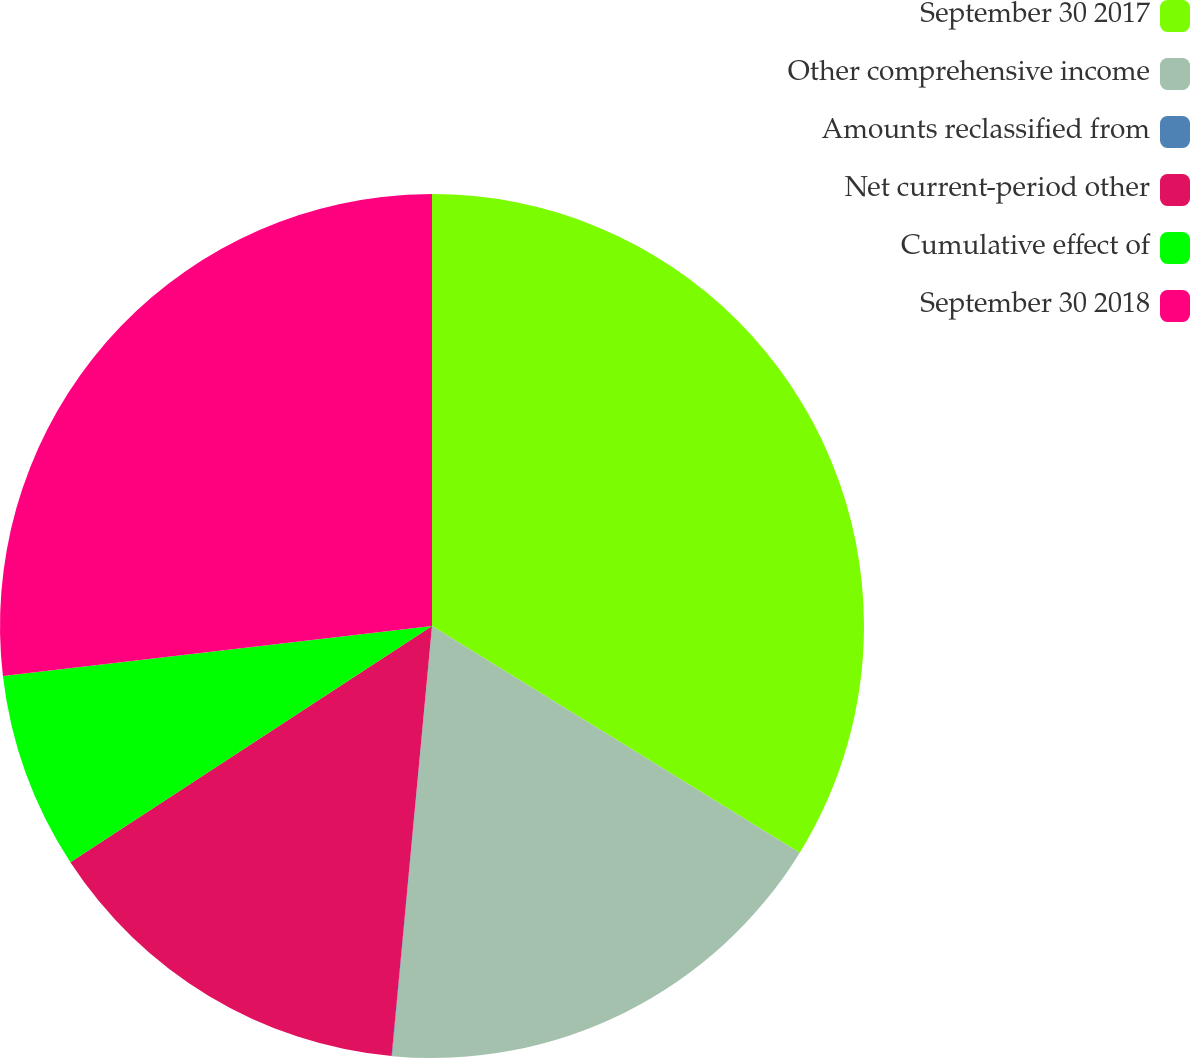Convert chart to OTSL. <chart><loc_0><loc_0><loc_500><loc_500><pie_chart><fcel>September 30 2017<fcel>Other comprehensive income<fcel>Amounts reclassified from<fcel>Net current-period other<fcel>Cumulative effect of<fcel>September 30 2018<nl><fcel>33.79%<fcel>17.68%<fcel>0.02%<fcel>14.3%<fcel>7.36%<fcel>26.85%<nl></chart> 